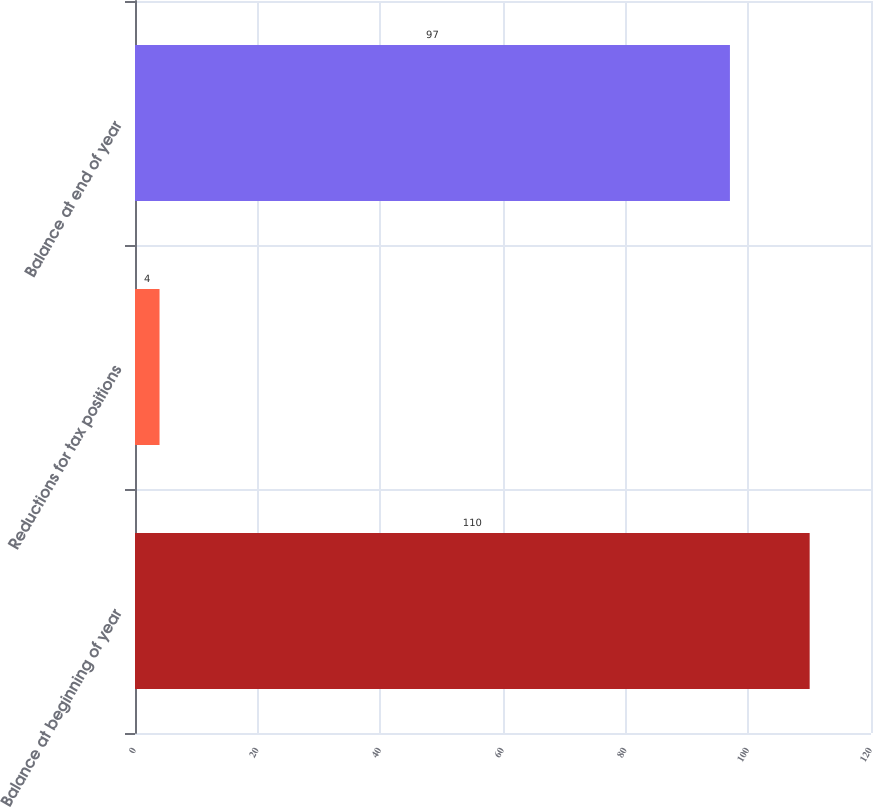Convert chart. <chart><loc_0><loc_0><loc_500><loc_500><bar_chart><fcel>Balance at beginning of year<fcel>Reductions for tax positions<fcel>Balance at end of year<nl><fcel>110<fcel>4<fcel>97<nl></chart> 